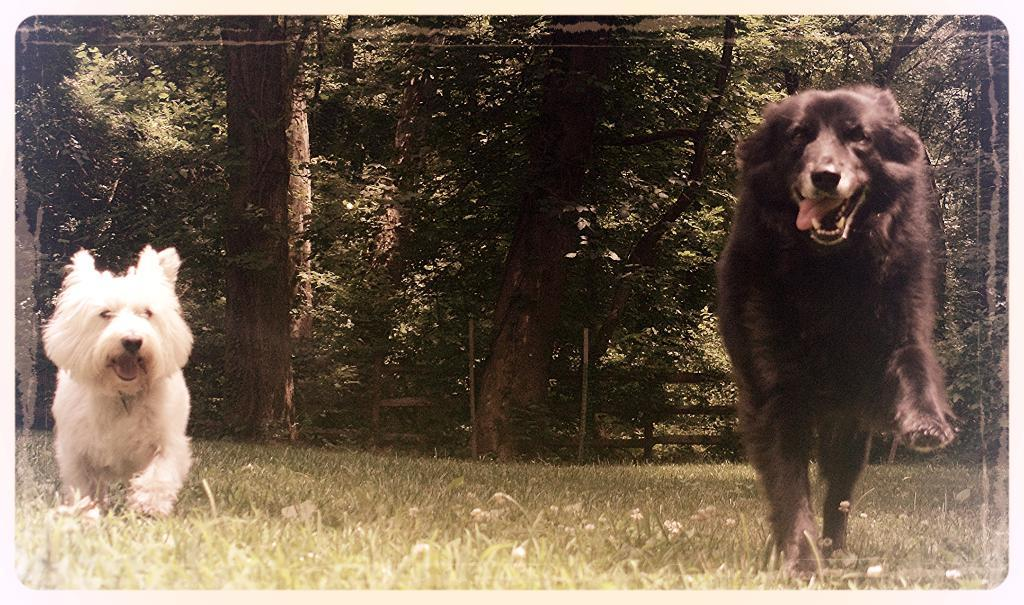How many dogs are in the image? There are two dogs in the image, one on the right side and one on the left side. What can be seen in the background of the image? Trees and wooden fencing are visible in the background of the image. What type of surface is present at the bottom of the image? Grass is present at the bottom of the image. Can you see the deer taking a breath in the image? There is no deer present in the image, so it is not possible to see it taking a breath. 